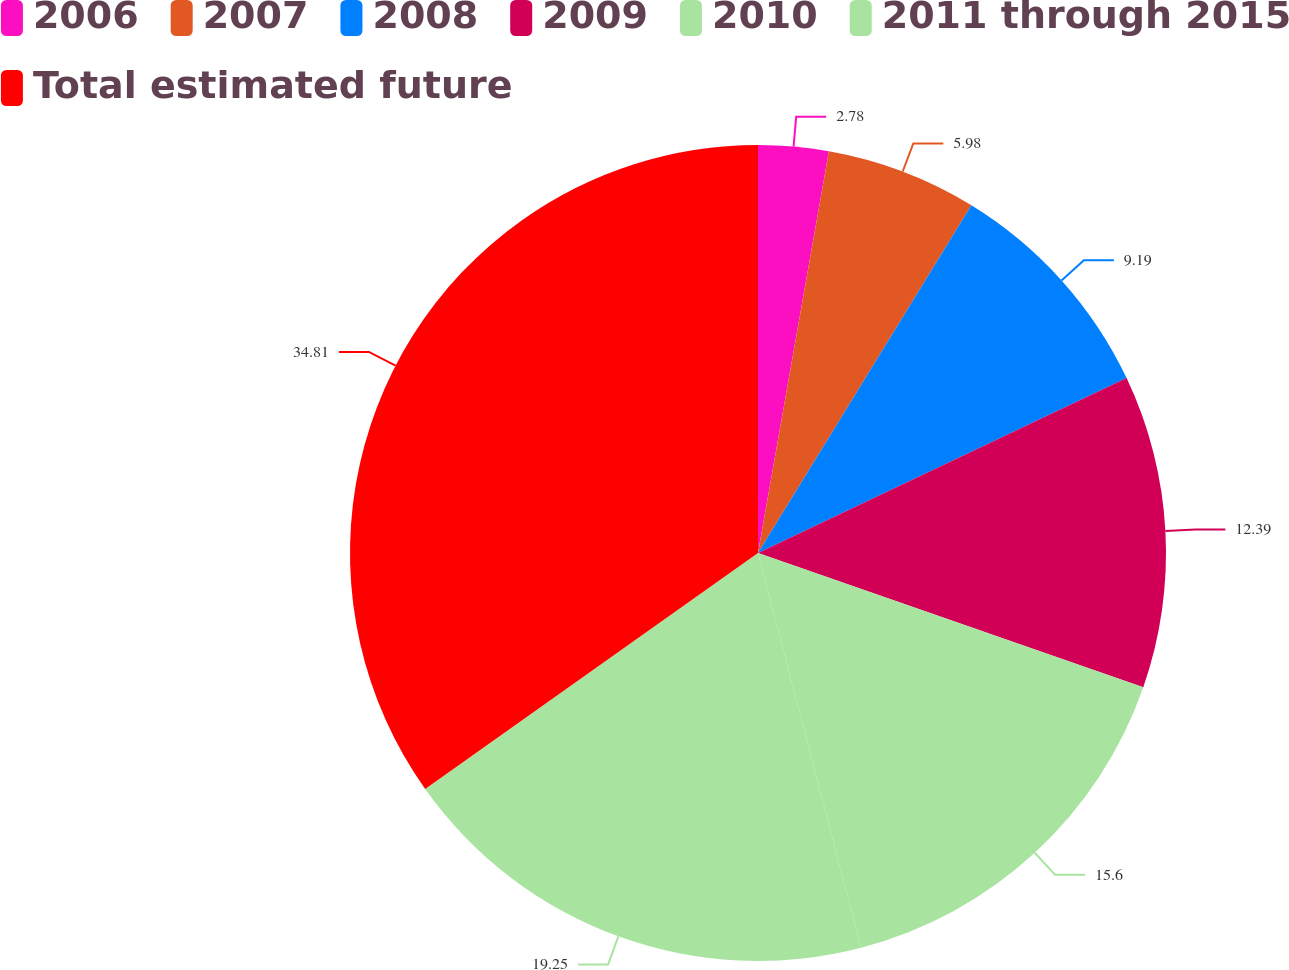Convert chart. <chart><loc_0><loc_0><loc_500><loc_500><pie_chart><fcel>2006<fcel>2007<fcel>2008<fcel>2009<fcel>2010<fcel>2011 through 2015<fcel>Total estimated future<nl><fcel>2.78%<fcel>5.98%<fcel>9.19%<fcel>12.39%<fcel>15.6%<fcel>19.25%<fcel>34.82%<nl></chart> 